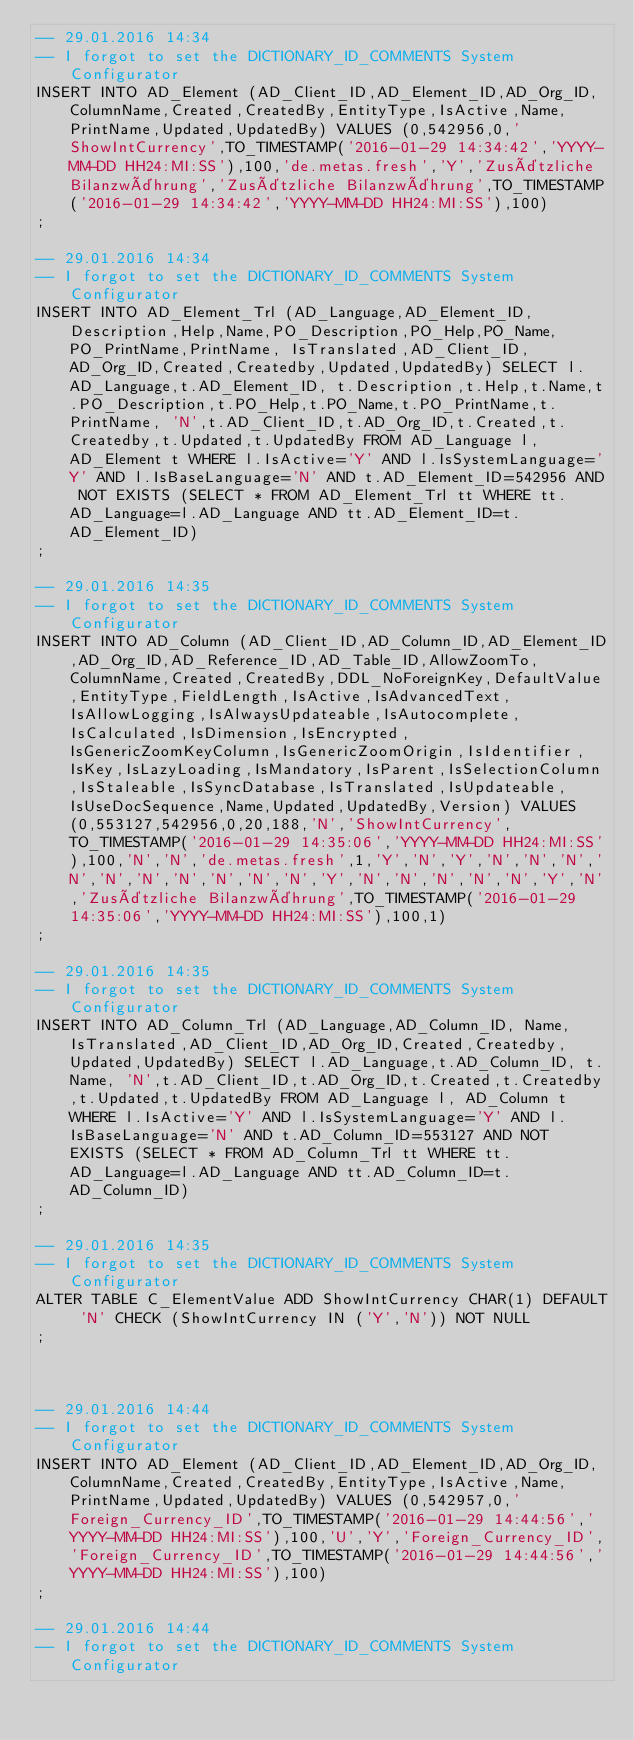Convert code to text. <code><loc_0><loc_0><loc_500><loc_500><_SQL_>-- 29.01.2016 14:34
-- I forgot to set the DICTIONARY_ID_COMMENTS System Configurator
INSERT INTO AD_Element (AD_Client_ID,AD_Element_ID,AD_Org_ID,ColumnName,Created,CreatedBy,EntityType,IsActive,Name,PrintName,Updated,UpdatedBy) VALUES (0,542956,0,'ShowIntCurrency',TO_TIMESTAMP('2016-01-29 14:34:42','YYYY-MM-DD HH24:MI:SS'),100,'de.metas.fresh','Y','Zusätzliche Bilanzwährung','Zusätzliche Bilanzwährung',TO_TIMESTAMP('2016-01-29 14:34:42','YYYY-MM-DD HH24:MI:SS'),100)
;

-- 29.01.2016 14:34
-- I forgot to set the DICTIONARY_ID_COMMENTS System Configurator
INSERT INTO AD_Element_Trl (AD_Language,AD_Element_ID, Description,Help,Name,PO_Description,PO_Help,PO_Name,PO_PrintName,PrintName, IsTranslated,AD_Client_ID,AD_Org_ID,Created,Createdby,Updated,UpdatedBy) SELECT l.AD_Language,t.AD_Element_ID, t.Description,t.Help,t.Name,t.PO_Description,t.PO_Help,t.PO_Name,t.PO_PrintName,t.PrintName, 'N',t.AD_Client_ID,t.AD_Org_ID,t.Created,t.Createdby,t.Updated,t.UpdatedBy FROM AD_Language l, AD_Element t WHERE l.IsActive='Y' AND l.IsSystemLanguage='Y' AND l.IsBaseLanguage='N' AND t.AD_Element_ID=542956 AND NOT EXISTS (SELECT * FROM AD_Element_Trl tt WHERE tt.AD_Language=l.AD_Language AND tt.AD_Element_ID=t.AD_Element_ID)
;

-- 29.01.2016 14:35
-- I forgot to set the DICTIONARY_ID_COMMENTS System Configurator
INSERT INTO AD_Column (AD_Client_ID,AD_Column_ID,AD_Element_ID,AD_Org_ID,AD_Reference_ID,AD_Table_ID,AllowZoomTo,ColumnName,Created,CreatedBy,DDL_NoForeignKey,DefaultValue,EntityType,FieldLength,IsActive,IsAdvancedText,IsAllowLogging,IsAlwaysUpdateable,IsAutocomplete,IsCalculated,IsDimension,IsEncrypted,IsGenericZoomKeyColumn,IsGenericZoomOrigin,IsIdentifier,IsKey,IsLazyLoading,IsMandatory,IsParent,IsSelectionColumn,IsStaleable,IsSyncDatabase,IsTranslated,IsUpdateable,IsUseDocSequence,Name,Updated,UpdatedBy,Version) VALUES (0,553127,542956,0,20,188,'N','ShowIntCurrency',TO_TIMESTAMP('2016-01-29 14:35:06','YYYY-MM-DD HH24:MI:SS'),100,'N','N','de.metas.fresh',1,'Y','N','Y','N','N','N','N','N','N','N','N','N','N','Y','N','N','N','N','N','Y','N','Zusätzliche Bilanzwährung',TO_TIMESTAMP('2016-01-29 14:35:06','YYYY-MM-DD HH24:MI:SS'),100,1)
;

-- 29.01.2016 14:35
-- I forgot to set the DICTIONARY_ID_COMMENTS System Configurator
INSERT INTO AD_Column_Trl (AD_Language,AD_Column_ID, Name, IsTranslated,AD_Client_ID,AD_Org_ID,Created,Createdby,Updated,UpdatedBy) SELECT l.AD_Language,t.AD_Column_ID, t.Name, 'N',t.AD_Client_ID,t.AD_Org_ID,t.Created,t.Createdby,t.Updated,t.UpdatedBy FROM AD_Language l, AD_Column t WHERE l.IsActive='Y' AND l.IsSystemLanguage='Y' AND l.IsBaseLanguage='N' AND t.AD_Column_ID=553127 AND NOT EXISTS (SELECT * FROM AD_Column_Trl tt WHERE tt.AD_Language=l.AD_Language AND tt.AD_Column_ID=t.AD_Column_ID)
;

-- 29.01.2016 14:35
-- I forgot to set the DICTIONARY_ID_COMMENTS System Configurator
ALTER TABLE C_ElementValue ADD ShowIntCurrency CHAR(1) DEFAULT 'N' CHECK (ShowIntCurrency IN ('Y','N')) NOT NULL
;



-- 29.01.2016 14:44
-- I forgot to set the DICTIONARY_ID_COMMENTS System Configurator
INSERT INTO AD_Element (AD_Client_ID,AD_Element_ID,AD_Org_ID,ColumnName,Created,CreatedBy,EntityType,IsActive,Name,PrintName,Updated,UpdatedBy) VALUES (0,542957,0,'Foreign_Currency_ID',TO_TIMESTAMP('2016-01-29 14:44:56','YYYY-MM-DD HH24:MI:SS'),100,'U','Y','Foreign_Currency_ID','Foreign_Currency_ID',TO_TIMESTAMP('2016-01-29 14:44:56','YYYY-MM-DD HH24:MI:SS'),100)
;

-- 29.01.2016 14:44
-- I forgot to set the DICTIONARY_ID_COMMENTS System Configurator</code> 